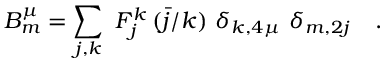Convert formula to latex. <formula><loc_0><loc_0><loc_500><loc_500>B _ { m } ^ { \mu } = \sum _ { j , k } \ F _ { j } ^ { k } \, ( \bar { j } / k ) \ \delta _ { k , 4 \mu } \ \delta _ { m , 2 j } \quad .</formula> 